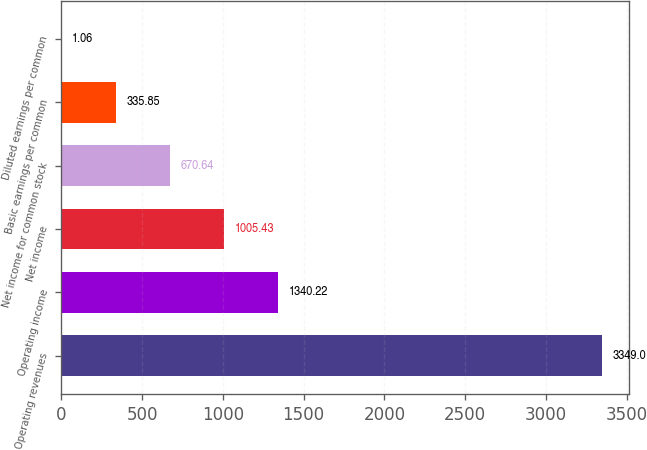Convert chart. <chart><loc_0><loc_0><loc_500><loc_500><bar_chart><fcel>Operating revenues<fcel>Operating income<fcel>Net income<fcel>Net income for common stock<fcel>Basic earnings per common<fcel>Diluted earnings per common<nl><fcel>3349<fcel>1340.22<fcel>1005.43<fcel>670.64<fcel>335.85<fcel>1.06<nl></chart> 